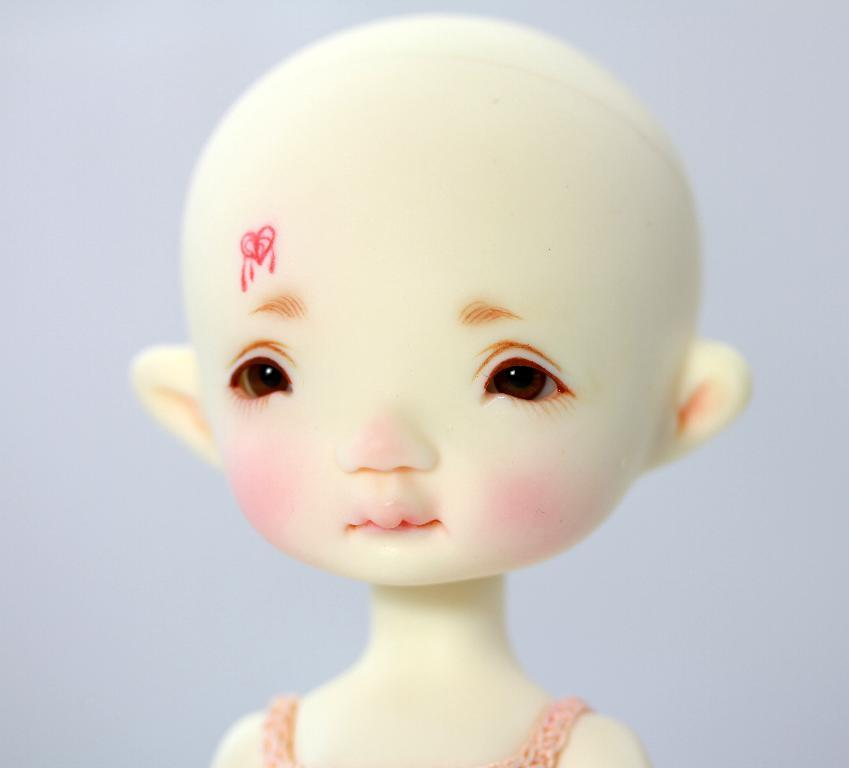What is the main subject of the image? There is a doll in the image. What does the doll resemble? The doll resembles a girl. What is the doll wearing? The doll is wearing a pink dress. What can be seen in the background of the image? There is a white wall visible in the background of the image. What type of industry is depicted in the image? There is no industry depicted in the image; it features a doll wearing a pink dress. Can you see a wrench being used by the doll in the image? There is no wrench present in the image; it only shows a doll wearing a pink dress. 